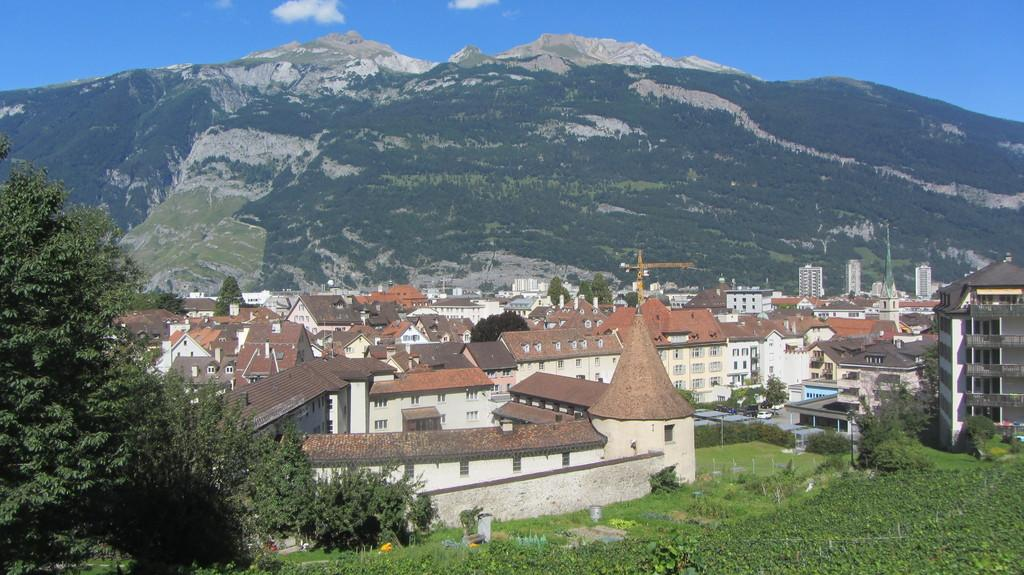What type of structures can be seen in the image? There are buildings in the image. What natural elements are present in the image? There are trees and plants in the image. What type of machinery is visible in the image? There is a crane in the image. What geographical feature can be seen in the image? There is a hill in the image. How would you describe the sky in the image? The sky is blue and cloudy in the image. What type of light is being used to illuminate the letter on the linen in the image? There is no letter or linen present in the image, and therefore no such lighting can be observed. 